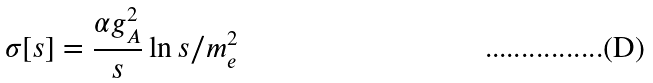<formula> <loc_0><loc_0><loc_500><loc_500>\sigma [ s ] = \frac { \alpha g _ { A } ^ { 2 } } { s } \ln s / m _ { e } ^ { 2 }</formula> 